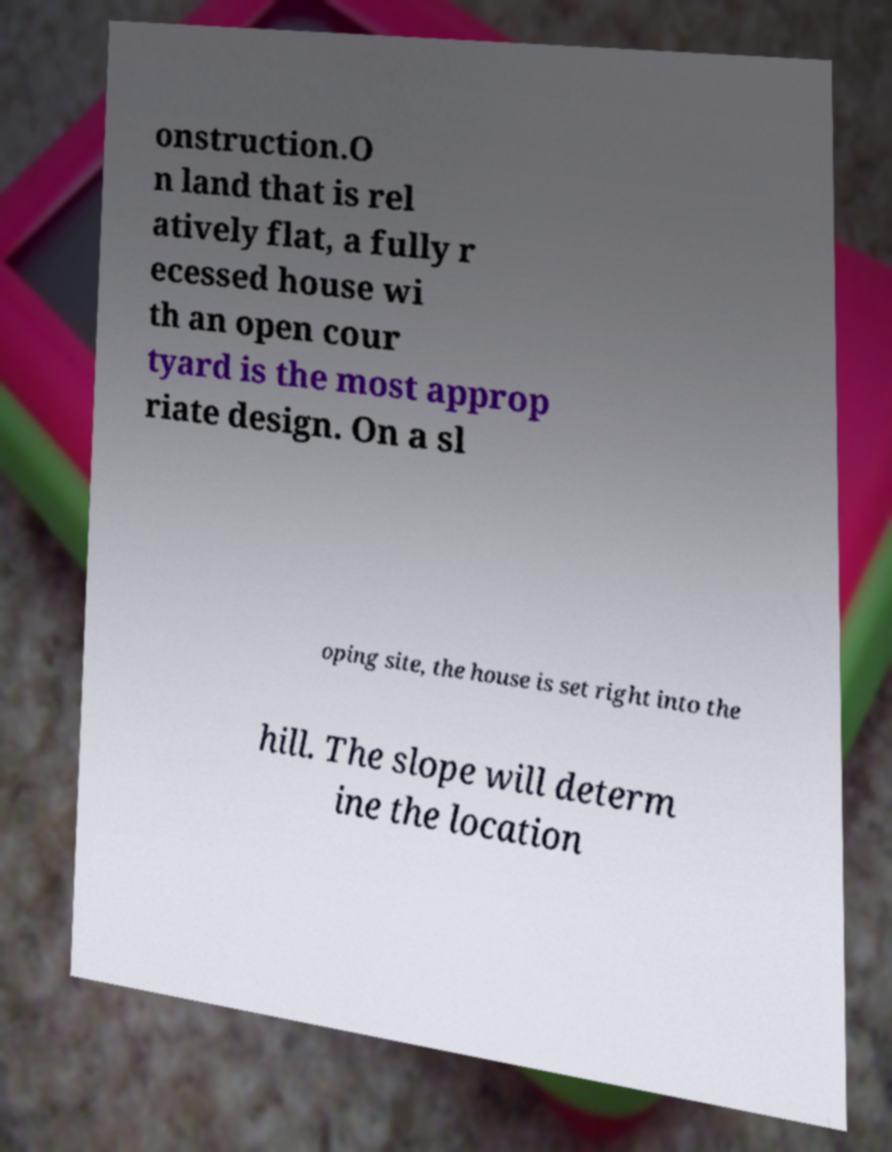I need the written content from this picture converted into text. Can you do that? onstruction.O n land that is rel atively flat, a fully r ecessed house wi th an open cour tyard is the most approp riate design. On a sl oping site, the house is set right into the hill. The slope will determ ine the location 